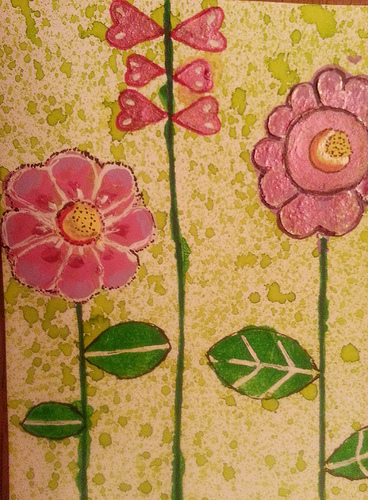<image>
Can you confirm if the leaf is next to the stem? Yes. The leaf is positioned adjacent to the stem, located nearby in the same general area. 